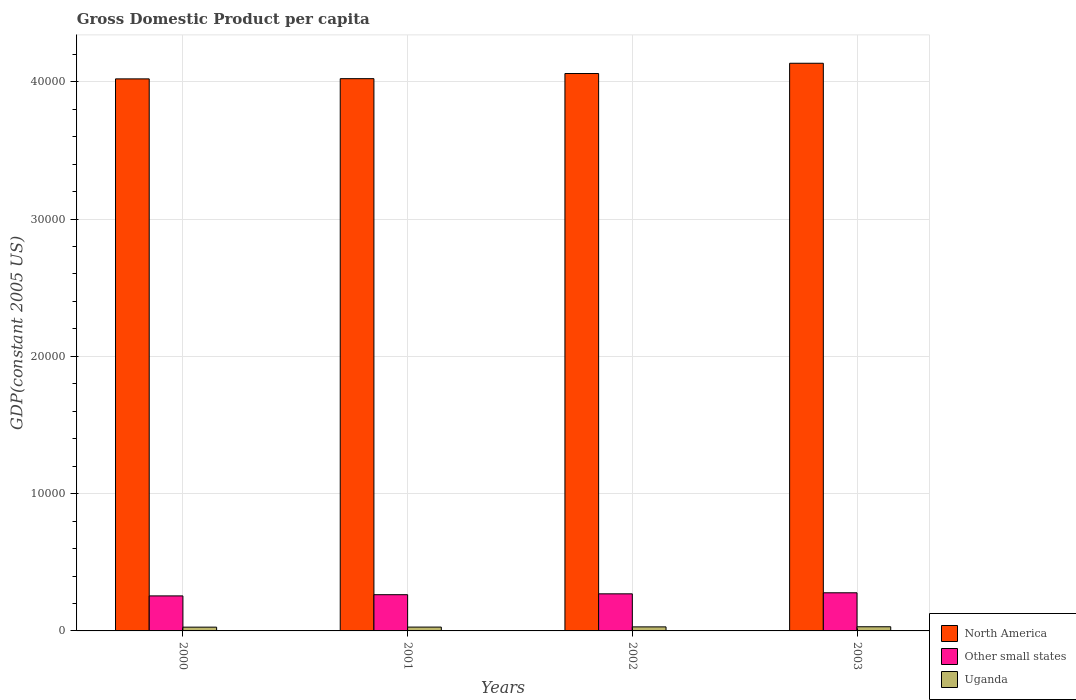How many different coloured bars are there?
Keep it short and to the point. 3. Are the number of bars per tick equal to the number of legend labels?
Offer a very short reply. Yes. How many bars are there on the 2nd tick from the right?
Offer a terse response. 3. What is the label of the 4th group of bars from the left?
Your answer should be compact. 2003. What is the GDP per capita in Other small states in 2001?
Keep it short and to the point. 2638.01. Across all years, what is the maximum GDP per capita in North America?
Make the answer very short. 4.13e+04. Across all years, what is the minimum GDP per capita in Uganda?
Your answer should be compact. 274.34. In which year was the GDP per capita in North America maximum?
Make the answer very short. 2003. In which year was the GDP per capita in Uganda minimum?
Provide a short and direct response. 2000. What is the total GDP per capita in Other small states in the graph?
Provide a short and direct response. 1.07e+04. What is the difference between the GDP per capita in Other small states in 2000 and that in 2002?
Provide a short and direct response. -150.68. What is the difference between the GDP per capita in Other small states in 2003 and the GDP per capita in Uganda in 2002?
Keep it short and to the point. 2482.9. What is the average GDP per capita in Uganda per year?
Provide a short and direct response. 287.62. In the year 2001, what is the difference between the GDP per capita in North America and GDP per capita in Other small states?
Keep it short and to the point. 3.76e+04. What is the ratio of the GDP per capita in North America in 2002 to that in 2003?
Your answer should be very brief. 0.98. Is the difference between the GDP per capita in North America in 2002 and 2003 greater than the difference between the GDP per capita in Other small states in 2002 and 2003?
Offer a very short reply. No. What is the difference between the highest and the second highest GDP per capita in Uganda?
Keep it short and to the point. 8.74. What is the difference between the highest and the lowest GDP per capita in Uganda?
Provide a short and direct response. 28.38. In how many years, is the GDP per capita in Other small states greater than the average GDP per capita in Other small states taken over all years?
Keep it short and to the point. 2. Is the sum of the GDP per capita in Other small states in 2001 and 2003 greater than the maximum GDP per capita in North America across all years?
Your answer should be compact. No. What does the 2nd bar from the left in 2000 represents?
Offer a terse response. Other small states. Are all the bars in the graph horizontal?
Provide a succinct answer. No. What is the difference between two consecutive major ticks on the Y-axis?
Provide a succinct answer. 10000. Are the values on the major ticks of Y-axis written in scientific E-notation?
Your answer should be very brief. No. How are the legend labels stacked?
Ensure brevity in your answer.  Vertical. What is the title of the graph?
Ensure brevity in your answer.  Gross Domestic Product per capita. What is the label or title of the X-axis?
Provide a succinct answer. Years. What is the label or title of the Y-axis?
Ensure brevity in your answer.  GDP(constant 2005 US). What is the GDP(constant 2005 US) of North America in 2000?
Keep it short and to the point. 4.02e+04. What is the GDP(constant 2005 US) of Other small states in 2000?
Ensure brevity in your answer.  2550.39. What is the GDP(constant 2005 US) of Uganda in 2000?
Your answer should be compact. 274.34. What is the GDP(constant 2005 US) in North America in 2001?
Ensure brevity in your answer.  4.02e+04. What is the GDP(constant 2005 US) of Other small states in 2001?
Ensure brevity in your answer.  2638.01. What is the GDP(constant 2005 US) in Uganda in 2001?
Your answer should be very brief. 279.42. What is the GDP(constant 2005 US) of North America in 2002?
Offer a terse response. 4.06e+04. What is the GDP(constant 2005 US) of Other small states in 2002?
Give a very brief answer. 2701.07. What is the GDP(constant 2005 US) in Uganda in 2002?
Make the answer very short. 293.98. What is the GDP(constant 2005 US) in North America in 2003?
Offer a terse response. 4.13e+04. What is the GDP(constant 2005 US) of Other small states in 2003?
Offer a terse response. 2776.89. What is the GDP(constant 2005 US) of Uganda in 2003?
Your response must be concise. 302.72. Across all years, what is the maximum GDP(constant 2005 US) of North America?
Your response must be concise. 4.13e+04. Across all years, what is the maximum GDP(constant 2005 US) of Other small states?
Provide a short and direct response. 2776.89. Across all years, what is the maximum GDP(constant 2005 US) of Uganda?
Keep it short and to the point. 302.72. Across all years, what is the minimum GDP(constant 2005 US) in North America?
Offer a very short reply. 4.02e+04. Across all years, what is the minimum GDP(constant 2005 US) in Other small states?
Ensure brevity in your answer.  2550.39. Across all years, what is the minimum GDP(constant 2005 US) in Uganda?
Your answer should be very brief. 274.34. What is the total GDP(constant 2005 US) in North America in the graph?
Offer a very short reply. 1.62e+05. What is the total GDP(constant 2005 US) of Other small states in the graph?
Ensure brevity in your answer.  1.07e+04. What is the total GDP(constant 2005 US) of Uganda in the graph?
Offer a very short reply. 1150.47. What is the difference between the GDP(constant 2005 US) of North America in 2000 and that in 2001?
Give a very brief answer. -15.76. What is the difference between the GDP(constant 2005 US) in Other small states in 2000 and that in 2001?
Your response must be concise. -87.62. What is the difference between the GDP(constant 2005 US) in Uganda in 2000 and that in 2001?
Your answer should be very brief. -5.08. What is the difference between the GDP(constant 2005 US) of North America in 2000 and that in 2002?
Ensure brevity in your answer.  -390.12. What is the difference between the GDP(constant 2005 US) of Other small states in 2000 and that in 2002?
Make the answer very short. -150.68. What is the difference between the GDP(constant 2005 US) of Uganda in 2000 and that in 2002?
Your response must be concise. -19.64. What is the difference between the GDP(constant 2005 US) in North America in 2000 and that in 2003?
Provide a succinct answer. -1137.54. What is the difference between the GDP(constant 2005 US) in Other small states in 2000 and that in 2003?
Give a very brief answer. -226.5. What is the difference between the GDP(constant 2005 US) of Uganda in 2000 and that in 2003?
Offer a terse response. -28.38. What is the difference between the GDP(constant 2005 US) of North America in 2001 and that in 2002?
Provide a short and direct response. -374.35. What is the difference between the GDP(constant 2005 US) of Other small states in 2001 and that in 2002?
Provide a short and direct response. -63.06. What is the difference between the GDP(constant 2005 US) in Uganda in 2001 and that in 2002?
Provide a succinct answer. -14.56. What is the difference between the GDP(constant 2005 US) in North America in 2001 and that in 2003?
Provide a short and direct response. -1121.77. What is the difference between the GDP(constant 2005 US) in Other small states in 2001 and that in 2003?
Give a very brief answer. -138.87. What is the difference between the GDP(constant 2005 US) in Uganda in 2001 and that in 2003?
Make the answer very short. -23.3. What is the difference between the GDP(constant 2005 US) of North America in 2002 and that in 2003?
Offer a terse response. -747.42. What is the difference between the GDP(constant 2005 US) in Other small states in 2002 and that in 2003?
Provide a succinct answer. -75.81. What is the difference between the GDP(constant 2005 US) of Uganda in 2002 and that in 2003?
Offer a terse response. -8.74. What is the difference between the GDP(constant 2005 US) of North America in 2000 and the GDP(constant 2005 US) of Other small states in 2001?
Provide a succinct answer. 3.76e+04. What is the difference between the GDP(constant 2005 US) of North America in 2000 and the GDP(constant 2005 US) of Uganda in 2001?
Provide a short and direct response. 3.99e+04. What is the difference between the GDP(constant 2005 US) in Other small states in 2000 and the GDP(constant 2005 US) in Uganda in 2001?
Offer a very short reply. 2270.97. What is the difference between the GDP(constant 2005 US) in North America in 2000 and the GDP(constant 2005 US) in Other small states in 2002?
Ensure brevity in your answer.  3.75e+04. What is the difference between the GDP(constant 2005 US) of North America in 2000 and the GDP(constant 2005 US) of Uganda in 2002?
Ensure brevity in your answer.  3.99e+04. What is the difference between the GDP(constant 2005 US) in Other small states in 2000 and the GDP(constant 2005 US) in Uganda in 2002?
Offer a very short reply. 2256.41. What is the difference between the GDP(constant 2005 US) of North America in 2000 and the GDP(constant 2005 US) of Other small states in 2003?
Offer a very short reply. 3.74e+04. What is the difference between the GDP(constant 2005 US) in North America in 2000 and the GDP(constant 2005 US) in Uganda in 2003?
Make the answer very short. 3.99e+04. What is the difference between the GDP(constant 2005 US) of Other small states in 2000 and the GDP(constant 2005 US) of Uganda in 2003?
Make the answer very short. 2247.67. What is the difference between the GDP(constant 2005 US) in North America in 2001 and the GDP(constant 2005 US) in Other small states in 2002?
Provide a short and direct response. 3.75e+04. What is the difference between the GDP(constant 2005 US) in North America in 2001 and the GDP(constant 2005 US) in Uganda in 2002?
Make the answer very short. 3.99e+04. What is the difference between the GDP(constant 2005 US) in Other small states in 2001 and the GDP(constant 2005 US) in Uganda in 2002?
Offer a terse response. 2344.03. What is the difference between the GDP(constant 2005 US) of North America in 2001 and the GDP(constant 2005 US) of Other small states in 2003?
Provide a short and direct response. 3.74e+04. What is the difference between the GDP(constant 2005 US) of North America in 2001 and the GDP(constant 2005 US) of Uganda in 2003?
Provide a succinct answer. 3.99e+04. What is the difference between the GDP(constant 2005 US) of Other small states in 2001 and the GDP(constant 2005 US) of Uganda in 2003?
Provide a short and direct response. 2335.29. What is the difference between the GDP(constant 2005 US) in North America in 2002 and the GDP(constant 2005 US) in Other small states in 2003?
Offer a terse response. 3.78e+04. What is the difference between the GDP(constant 2005 US) of North America in 2002 and the GDP(constant 2005 US) of Uganda in 2003?
Provide a short and direct response. 4.03e+04. What is the difference between the GDP(constant 2005 US) of Other small states in 2002 and the GDP(constant 2005 US) of Uganda in 2003?
Keep it short and to the point. 2398.35. What is the average GDP(constant 2005 US) in North America per year?
Ensure brevity in your answer.  4.06e+04. What is the average GDP(constant 2005 US) of Other small states per year?
Give a very brief answer. 2666.59. What is the average GDP(constant 2005 US) in Uganda per year?
Your answer should be very brief. 287.62. In the year 2000, what is the difference between the GDP(constant 2005 US) of North America and GDP(constant 2005 US) of Other small states?
Your answer should be very brief. 3.77e+04. In the year 2000, what is the difference between the GDP(constant 2005 US) in North America and GDP(constant 2005 US) in Uganda?
Keep it short and to the point. 3.99e+04. In the year 2000, what is the difference between the GDP(constant 2005 US) of Other small states and GDP(constant 2005 US) of Uganda?
Your answer should be compact. 2276.05. In the year 2001, what is the difference between the GDP(constant 2005 US) in North America and GDP(constant 2005 US) in Other small states?
Offer a terse response. 3.76e+04. In the year 2001, what is the difference between the GDP(constant 2005 US) of North America and GDP(constant 2005 US) of Uganda?
Offer a terse response. 3.99e+04. In the year 2001, what is the difference between the GDP(constant 2005 US) in Other small states and GDP(constant 2005 US) in Uganda?
Provide a succinct answer. 2358.59. In the year 2002, what is the difference between the GDP(constant 2005 US) in North America and GDP(constant 2005 US) in Other small states?
Offer a terse response. 3.79e+04. In the year 2002, what is the difference between the GDP(constant 2005 US) of North America and GDP(constant 2005 US) of Uganda?
Offer a very short reply. 4.03e+04. In the year 2002, what is the difference between the GDP(constant 2005 US) of Other small states and GDP(constant 2005 US) of Uganda?
Offer a terse response. 2407.09. In the year 2003, what is the difference between the GDP(constant 2005 US) in North America and GDP(constant 2005 US) in Other small states?
Provide a short and direct response. 3.86e+04. In the year 2003, what is the difference between the GDP(constant 2005 US) in North America and GDP(constant 2005 US) in Uganda?
Your response must be concise. 4.10e+04. In the year 2003, what is the difference between the GDP(constant 2005 US) in Other small states and GDP(constant 2005 US) in Uganda?
Offer a terse response. 2474.16. What is the ratio of the GDP(constant 2005 US) of Other small states in 2000 to that in 2001?
Provide a short and direct response. 0.97. What is the ratio of the GDP(constant 2005 US) in Uganda in 2000 to that in 2001?
Your answer should be very brief. 0.98. What is the ratio of the GDP(constant 2005 US) of Other small states in 2000 to that in 2002?
Ensure brevity in your answer.  0.94. What is the ratio of the GDP(constant 2005 US) in Uganda in 2000 to that in 2002?
Give a very brief answer. 0.93. What is the ratio of the GDP(constant 2005 US) of North America in 2000 to that in 2003?
Your response must be concise. 0.97. What is the ratio of the GDP(constant 2005 US) of Other small states in 2000 to that in 2003?
Offer a very short reply. 0.92. What is the ratio of the GDP(constant 2005 US) in Uganda in 2000 to that in 2003?
Make the answer very short. 0.91. What is the ratio of the GDP(constant 2005 US) of North America in 2001 to that in 2002?
Offer a very short reply. 0.99. What is the ratio of the GDP(constant 2005 US) of Other small states in 2001 to that in 2002?
Offer a terse response. 0.98. What is the ratio of the GDP(constant 2005 US) of Uganda in 2001 to that in 2002?
Keep it short and to the point. 0.95. What is the ratio of the GDP(constant 2005 US) of North America in 2001 to that in 2003?
Offer a terse response. 0.97. What is the ratio of the GDP(constant 2005 US) of Other small states in 2001 to that in 2003?
Your answer should be compact. 0.95. What is the ratio of the GDP(constant 2005 US) of Uganda in 2001 to that in 2003?
Ensure brevity in your answer.  0.92. What is the ratio of the GDP(constant 2005 US) in North America in 2002 to that in 2003?
Provide a short and direct response. 0.98. What is the ratio of the GDP(constant 2005 US) of Other small states in 2002 to that in 2003?
Give a very brief answer. 0.97. What is the ratio of the GDP(constant 2005 US) of Uganda in 2002 to that in 2003?
Your answer should be compact. 0.97. What is the difference between the highest and the second highest GDP(constant 2005 US) of North America?
Keep it short and to the point. 747.42. What is the difference between the highest and the second highest GDP(constant 2005 US) in Other small states?
Give a very brief answer. 75.81. What is the difference between the highest and the second highest GDP(constant 2005 US) in Uganda?
Provide a short and direct response. 8.74. What is the difference between the highest and the lowest GDP(constant 2005 US) of North America?
Keep it short and to the point. 1137.54. What is the difference between the highest and the lowest GDP(constant 2005 US) in Other small states?
Ensure brevity in your answer.  226.5. What is the difference between the highest and the lowest GDP(constant 2005 US) in Uganda?
Offer a terse response. 28.38. 